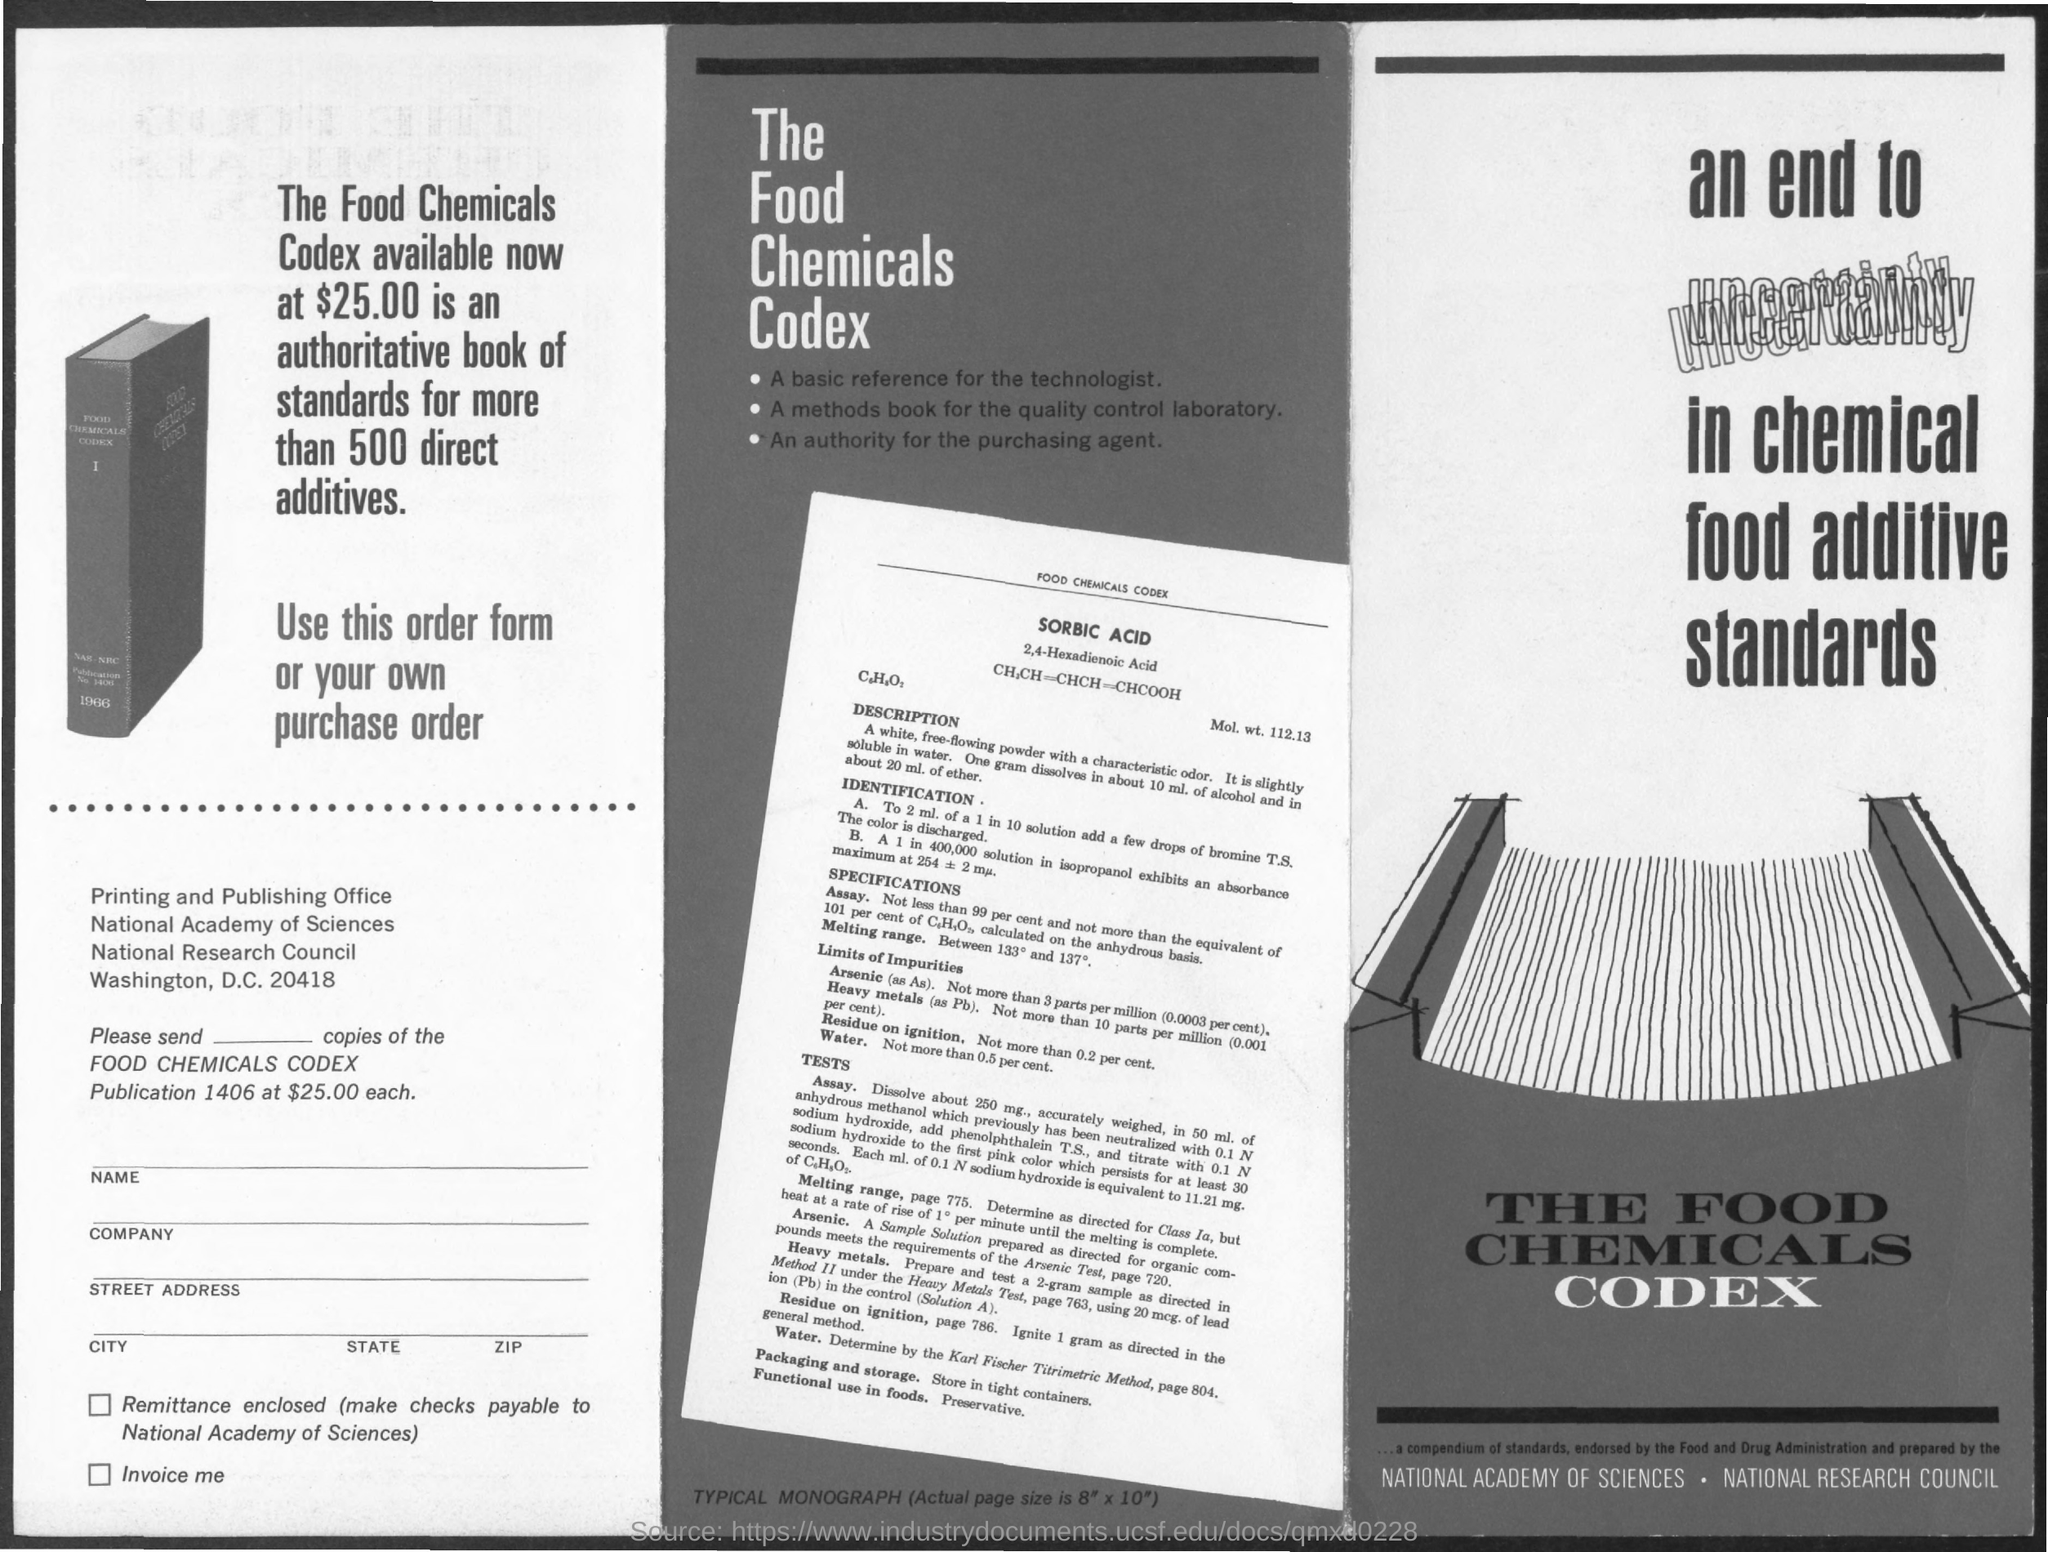Point out several critical features in this image. Sorbic acid is the kind of acid mentioned in the chemical compendium. The cost of the Food Chemicals Codex is $25.00. 